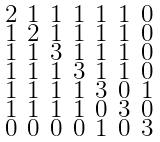Convert formula to latex. <formula><loc_0><loc_0><loc_500><loc_500>\begin{smallmatrix} 2 & 1 & 1 & 1 & 1 & 1 & 0 \\ 1 & 2 & 1 & 1 & 1 & 1 & 0 \\ 1 & 1 & 3 & 1 & 1 & 1 & 0 \\ 1 & 1 & 1 & 3 & 1 & 1 & 0 \\ 1 & 1 & 1 & 1 & 3 & 0 & 1 \\ 1 & 1 & 1 & 1 & 0 & 3 & 0 \\ 0 & 0 & 0 & 0 & 1 & 0 & 3 \end{smallmatrix}</formula> 